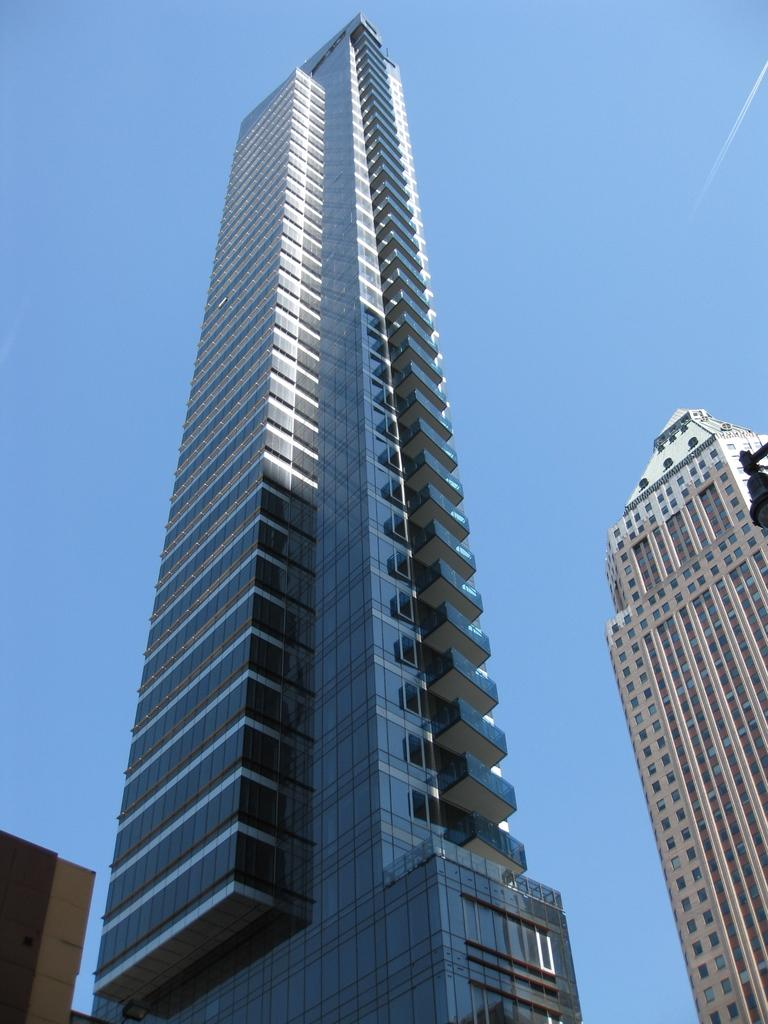What type of structures are present in the image? There are buildings in the image. Where are the buildings located in relation to the image? The buildings are at the front of the image. What can be seen in the background of the image? There is sky visible in the background of the image. Can you tell me what type of pet is sitting on the library's steps in the image? There is no library or pet present in the image; it features buildings and sky. 